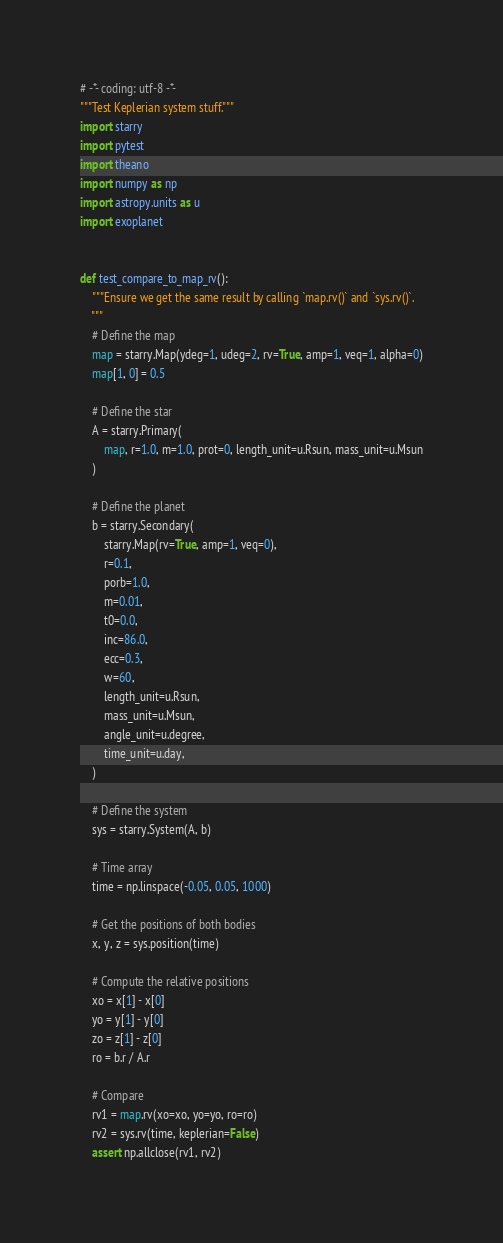<code> <loc_0><loc_0><loc_500><loc_500><_Python_># -*- coding: utf-8 -*-
"""Test Keplerian system stuff."""
import starry
import pytest
import theano
import numpy as np
import astropy.units as u
import exoplanet


def test_compare_to_map_rv():
    """Ensure we get the same result by calling `map.rv()` and `sys.rv()`.
    """
    # Define the map
    map = starry.Map(ydeg=1, udeg=2, rv=True, amp=1, veq=1, alpha=0)
    map[1, 0] = 0.5

    # Define the star
    A = starry.Primary(
        map, r=1.0, m=1.0, prot=0, length_unit=u.Rsun, mass_unit=u.Msun
    )

    # Define the planet
    b = starry.Secondary(
        starry.Map(rv=True, amp=1, veq=0),
        r=0.1,
        porb=1.0,
        m=0.01,
        t0=0.0,
        inc=86.0,
        ecc=0.3,
        w=60,
        length_unit=u.Rsun,
        mass_unit=u.Msun,
        angle_unit=u.degree,
        time_unit=u.day,
    )

    # Define the system
    sys = starry.System(A, b)

    # Time array
    time = np.linspace(-0.05, 0.05, 1000)

    # Get the positions of both bodies
    x, y, z = sys.position(time)

    # Compute the relative positions
    xo = x[1] - x[0]
    yo = y[1] - y[0]
    zo = z[1] - z[0]
    ro = b.r / A.r

    # Compare
    rv1 = map.rv(xo=xo, yo=yo, ro=ro)
    rv2 = sys.rv(time, keplerian=False)
    assert np.allclose(rv1, rv2)

</code> 